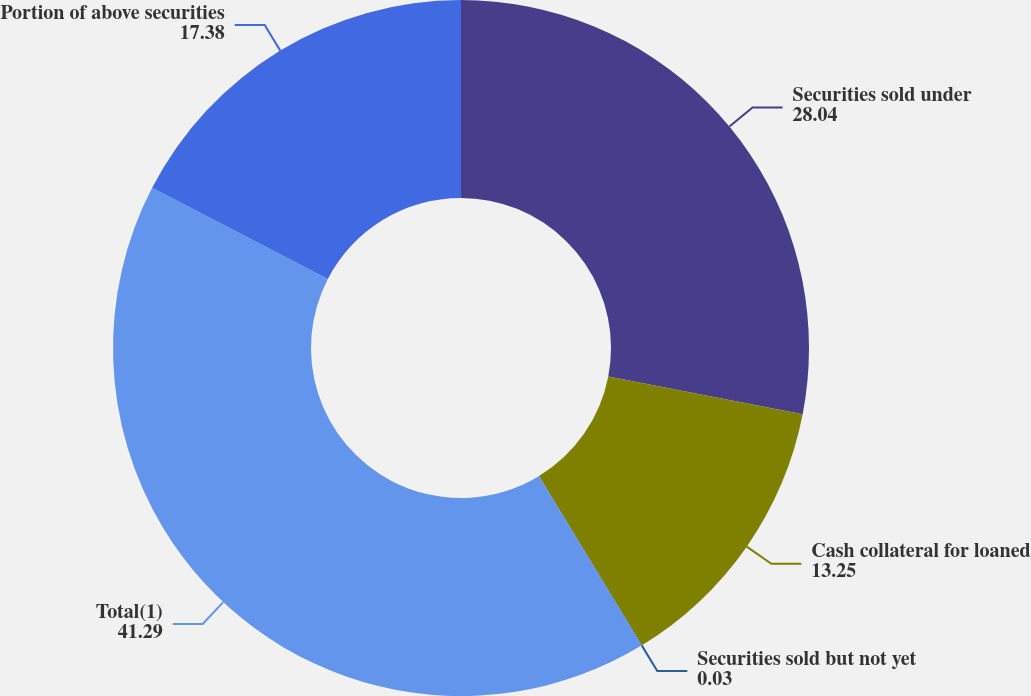Convert chart. <chart><loc_0><loc_0><loc_500><loc_500><pie_chart><fcel>Securities sold under<fcel>Cash collateral for loaned<fcel>Securities sold but not yet<fcel>Total(1)<fcel>Portion of above securities<nl><fcel>28.04%<fcel>13.25%<fcel>0.03%<fcel>41.29%<fcel>17.38%<nl></chart> 